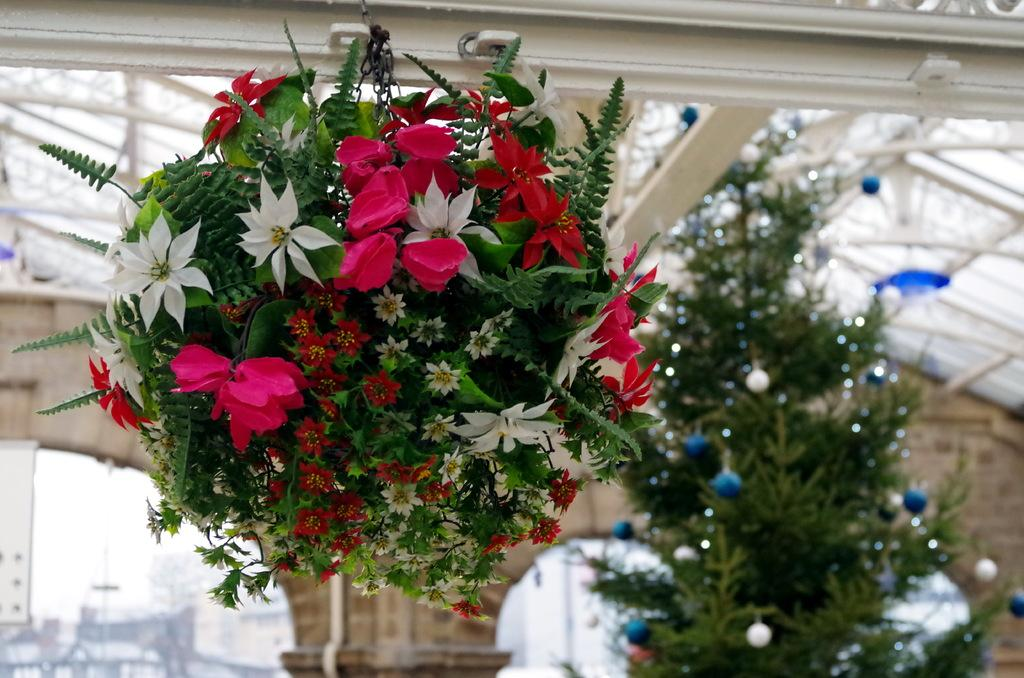What type of flowers are on the plant in the image? The plant in the image has pink, red, and white flowers. What is the tree in the background of the image decorated with? The tree in the background is decorated with balls and lights. What can be seen in the distance behind the plant and tree? Buildings and the sky are visible in the background of the image. What word is written on the face of the person in the image? There is no person or face present in the image; it features a plant with flowers and a decorated tree in the background. 